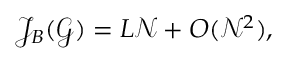Convert formula to latex. <formula><loc_0><loc_0><loc_500><loc_500>\begin{array} { r } { \mathcal { J } _ { B } ( \mathcal { G } ) = L \mathcal { N } + O ( \mathcal { N } ^ { 2 } ) , } \end{array}</formula> 